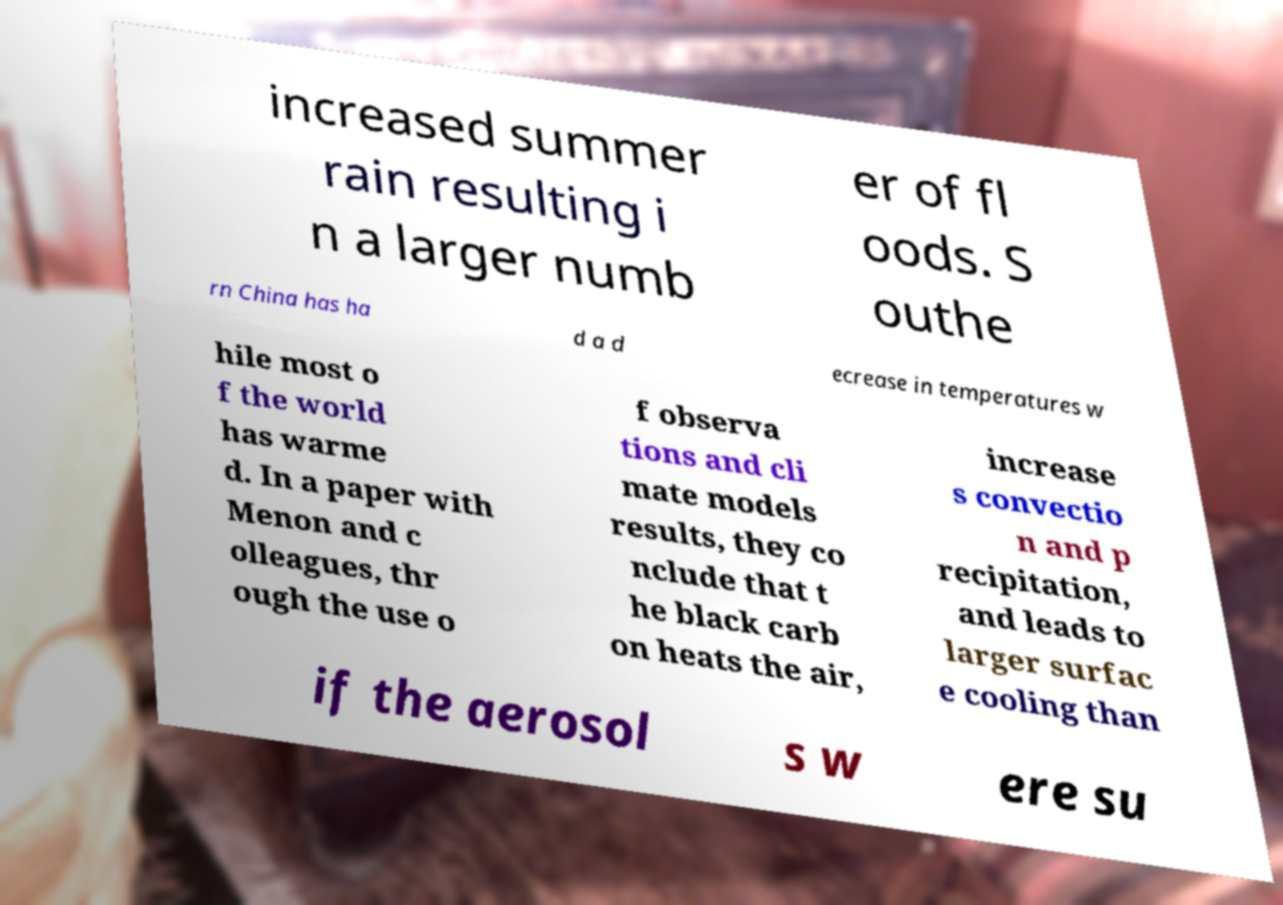Can you accurately transcribe the text from the provided image for me? increased summer rain resulting i n a larger numb er of fl oods. S outhe rn China has ha d a d ecrease in temperatures w hile most o f the world has warme d. In a paper with Menon and c olleagues, thr ough the use o f observa tions and cli mate models results, they co nclude that t he black carb on heats the air, increase s convectio n and p recipitation, and leads to larger surfac e cooling than if the aerosol s w ere su 